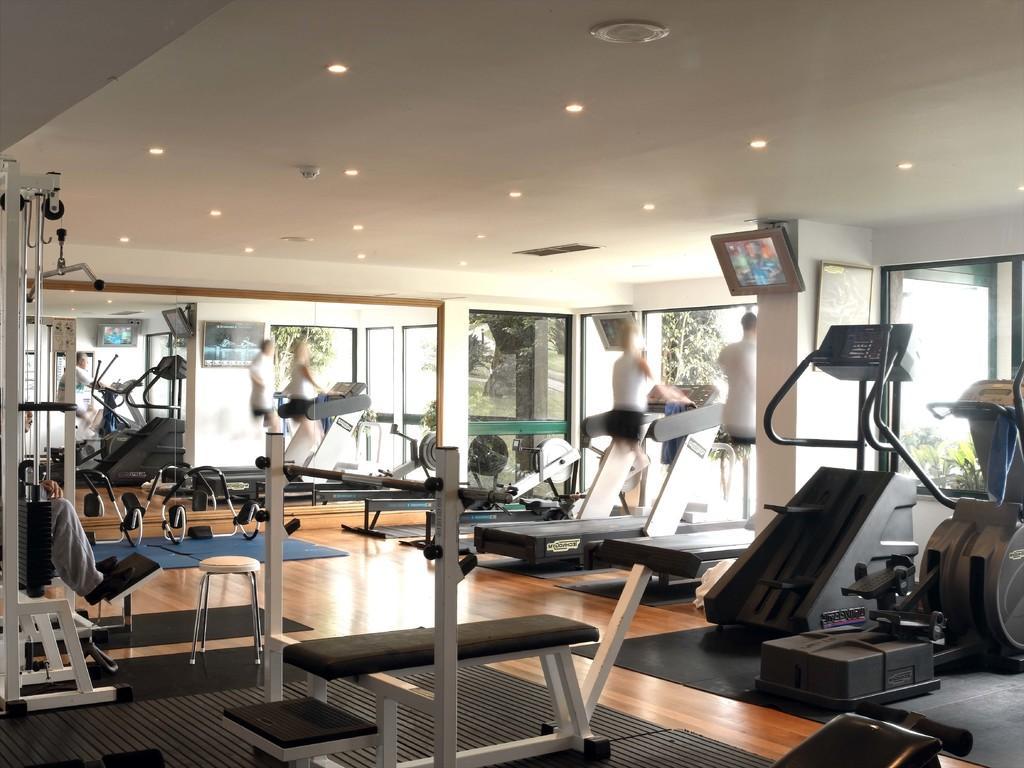Can you describe this image briefly? In this image we can see the inner view of the gymnasium. In the gymnasium we can see some persons doing exercises on the machines, benches, seating stools, wall hangings attached to the walls, display screens and electric lights to the roof. 